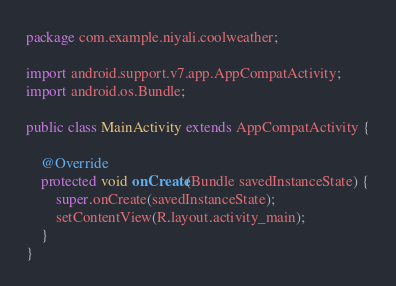Convert code to text. <code><loc_0><loc_0><loc_500><loc_500><_Java_>package com.example.niyali.coolweather;

import android.support.v7.app.AppCompatActivity;
import android.os.Bundle;

public class MainActivity extends AppCompatActivity {

    @Override
    protected void onCreate(Bundle savedInstanceState) {
        super.onCreate(savedInstanceState);
        setContentView(R.layout.activity_main);
    }
}
</code> 